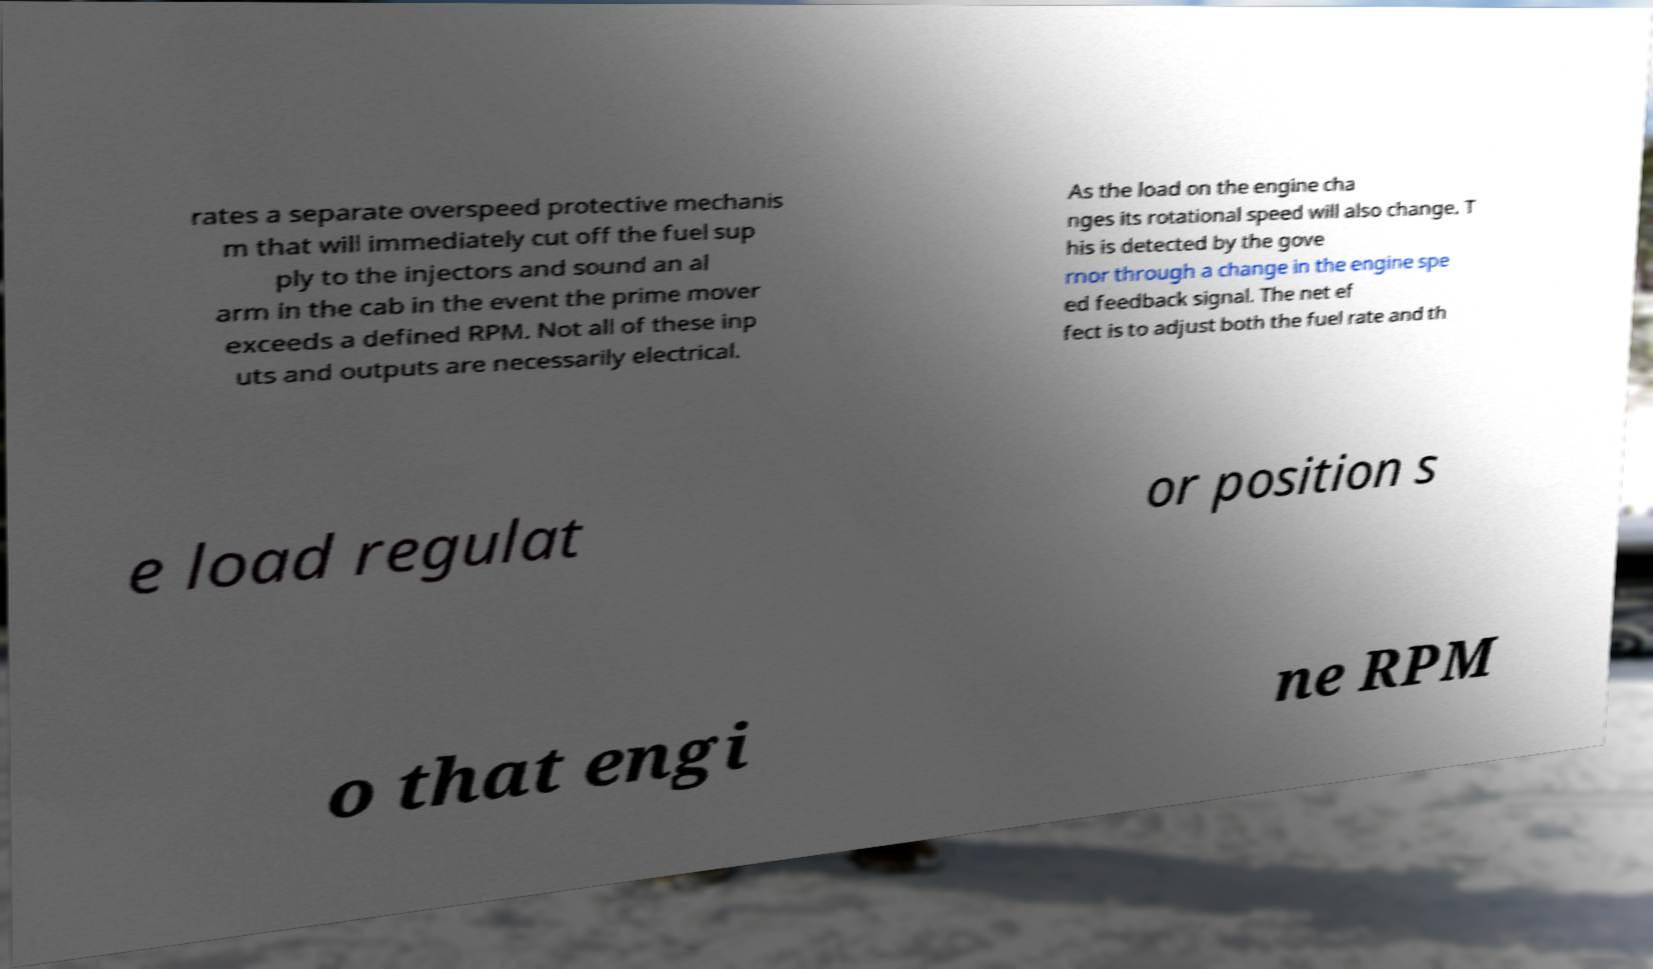Please read and relay the text visible in this image. What does it say? rates a separate overspeed protective mechanis m that will immediately cut off the fuel sup ply to the injectors and sound an al arm in the cab in the event the prime mover exceeds a defined RPM. Not all of these inp uts and outputs are necessarily electrical. As the load on the engine cha nges its rotational speed will also change. T his is detected by the gove rnor through a change in the engine spe ed feedback signal. The net ef fect is to adjust both the fuel rate and th e load regulat or position s o that engi ne RPM 